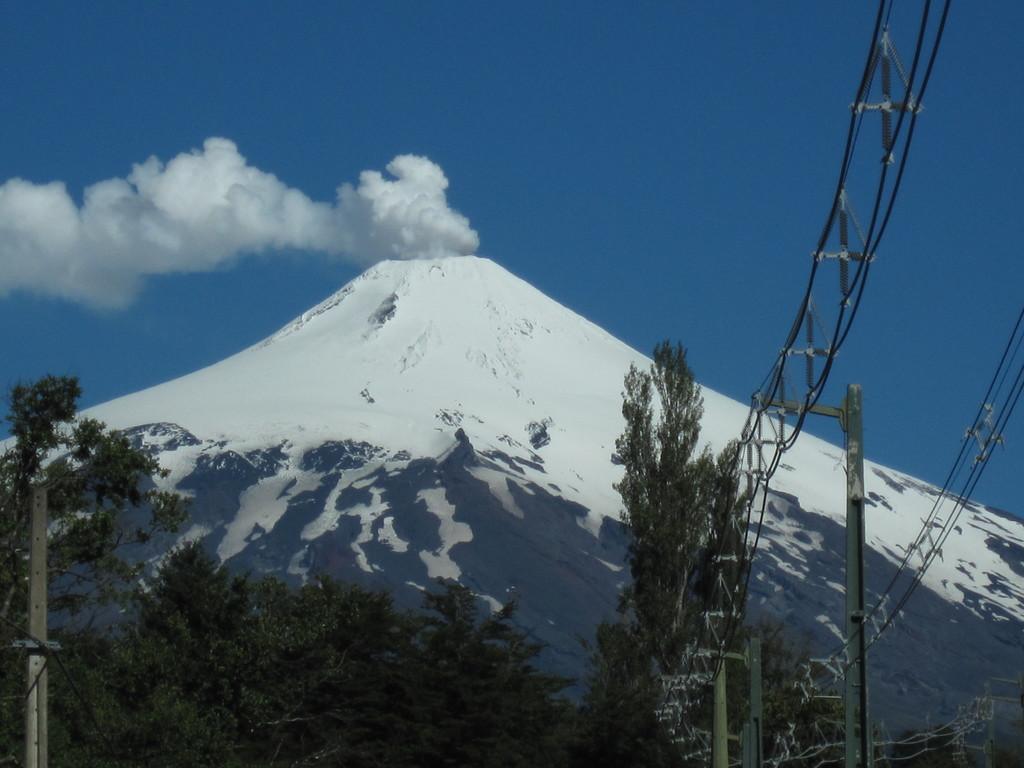Describe this image in one or two sentences. In this image I can see many trees. To the right there are wires. In the back I can see the mountains, smoke and the blue sky. 